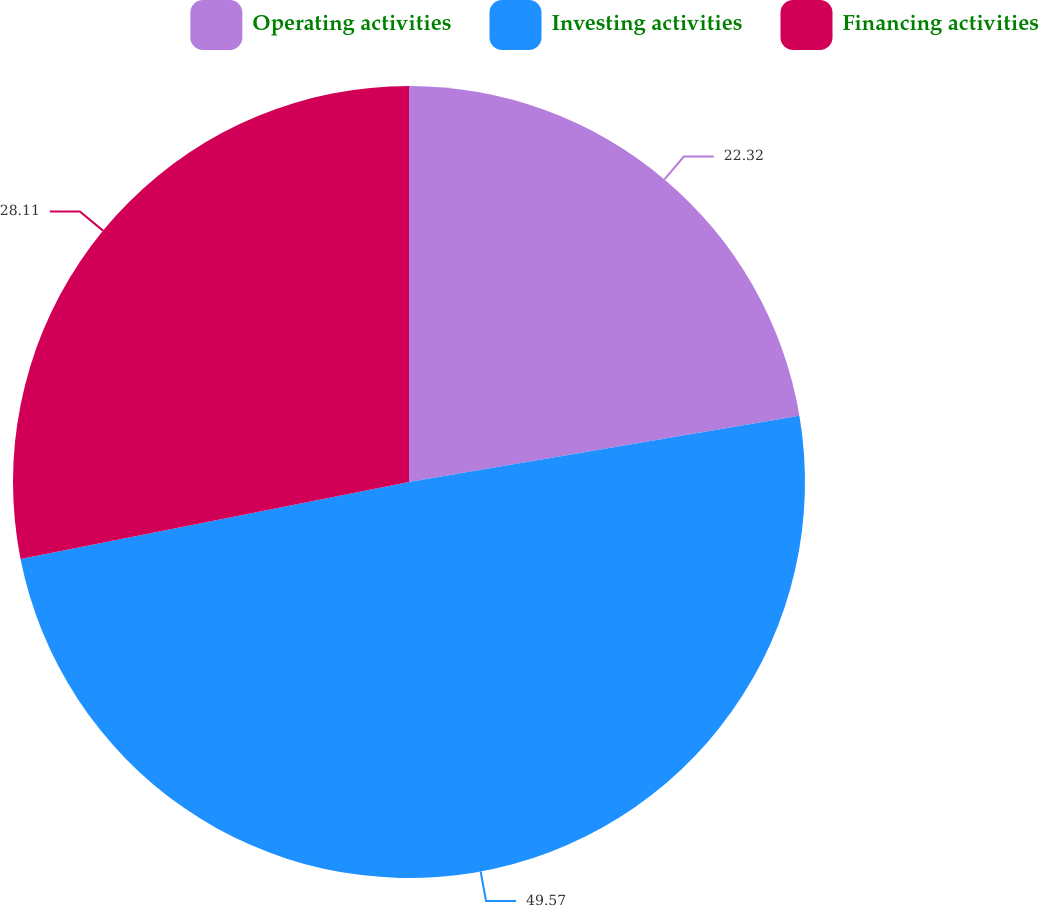Convert chart. <chart><loc_0><loc_0><loc_500><loc_500><pie_chart><fcel>Operating activities<fcel>Investing activities<fcel>Financing activities<nl><fcel>22.32%<fcel>49.57%<fcel>28.11%<nl></chart> 